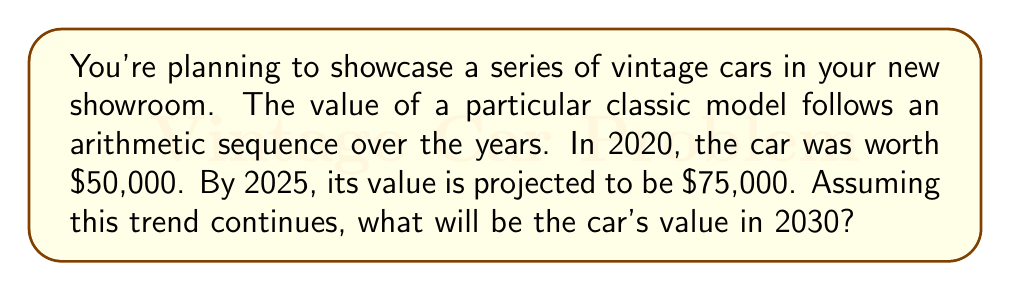Solve this math problem. Let's approach this step-by-step:

1) We have an arithmetic sequence where:
   - $a_1 = 50000$ (value in 2020)
   - $a_6 = 75000$ (value in 2025, 5 years later)

2) We need to find the common difference (d) of the sequence:
   $$a_6 = a_1 + 5d$$
   $$75000 = 50000 + 5d$$
   $$25000 = 5d$$
   $$d = 5000$$

3) So, the car's value increases by $5000 each year.

4) To find the value in 2030, we need to calculate $a_{11}$ (10 years from 2020):
   $$a_{11} = a_1 + 10d$$
   $$a_{11} = 50000 + 10(5000)$$
   $$a_{11} = 50000 + 50000$$
   $$a_{11} = 100000$$

Therefore, the car's value in 2030 will be $100,000.
Answer: $100,000 